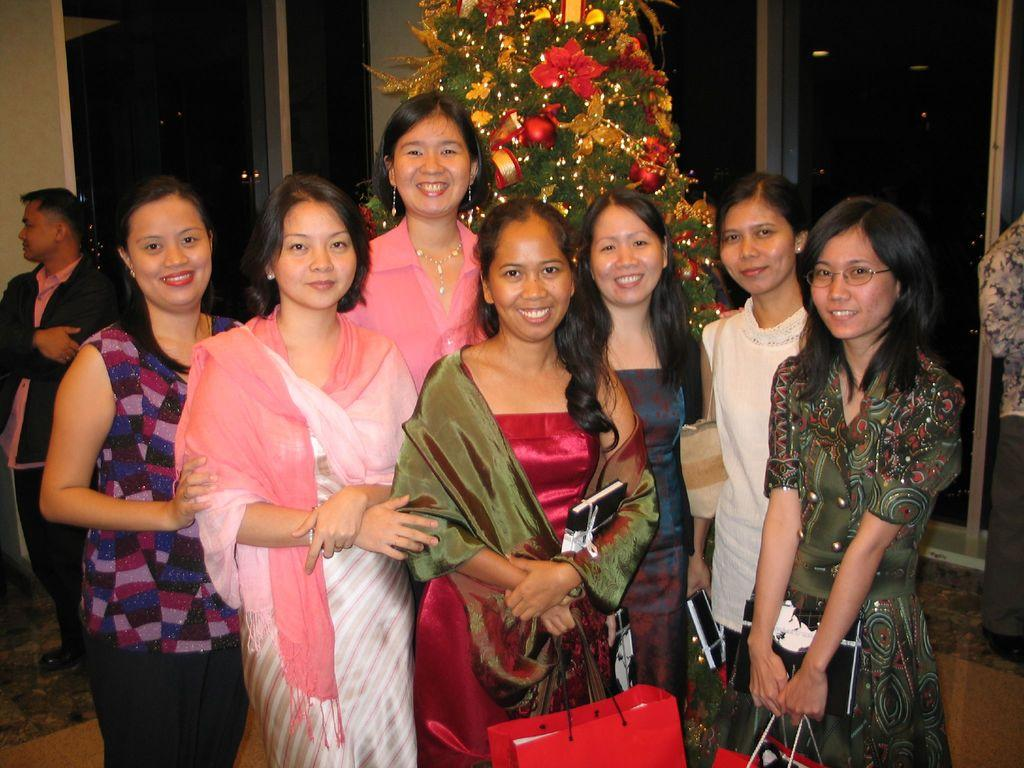How many people are in the group that is visible in the image? There is a group of people in the image. What are some of the people in the group doing? Some people in the group are smiling, and some are holding bags. What seasonal decoration can be seen in the image? There is a Christmas tree visible in the image. What is the color of the background in the image? The background of the image is dark. What type of skin is visible on the committee members in the image? There is no committee present in the image, and therefore no committee members with skin. What flavor of soda is being consumed by the people in the image? There is no soda present in the image. 